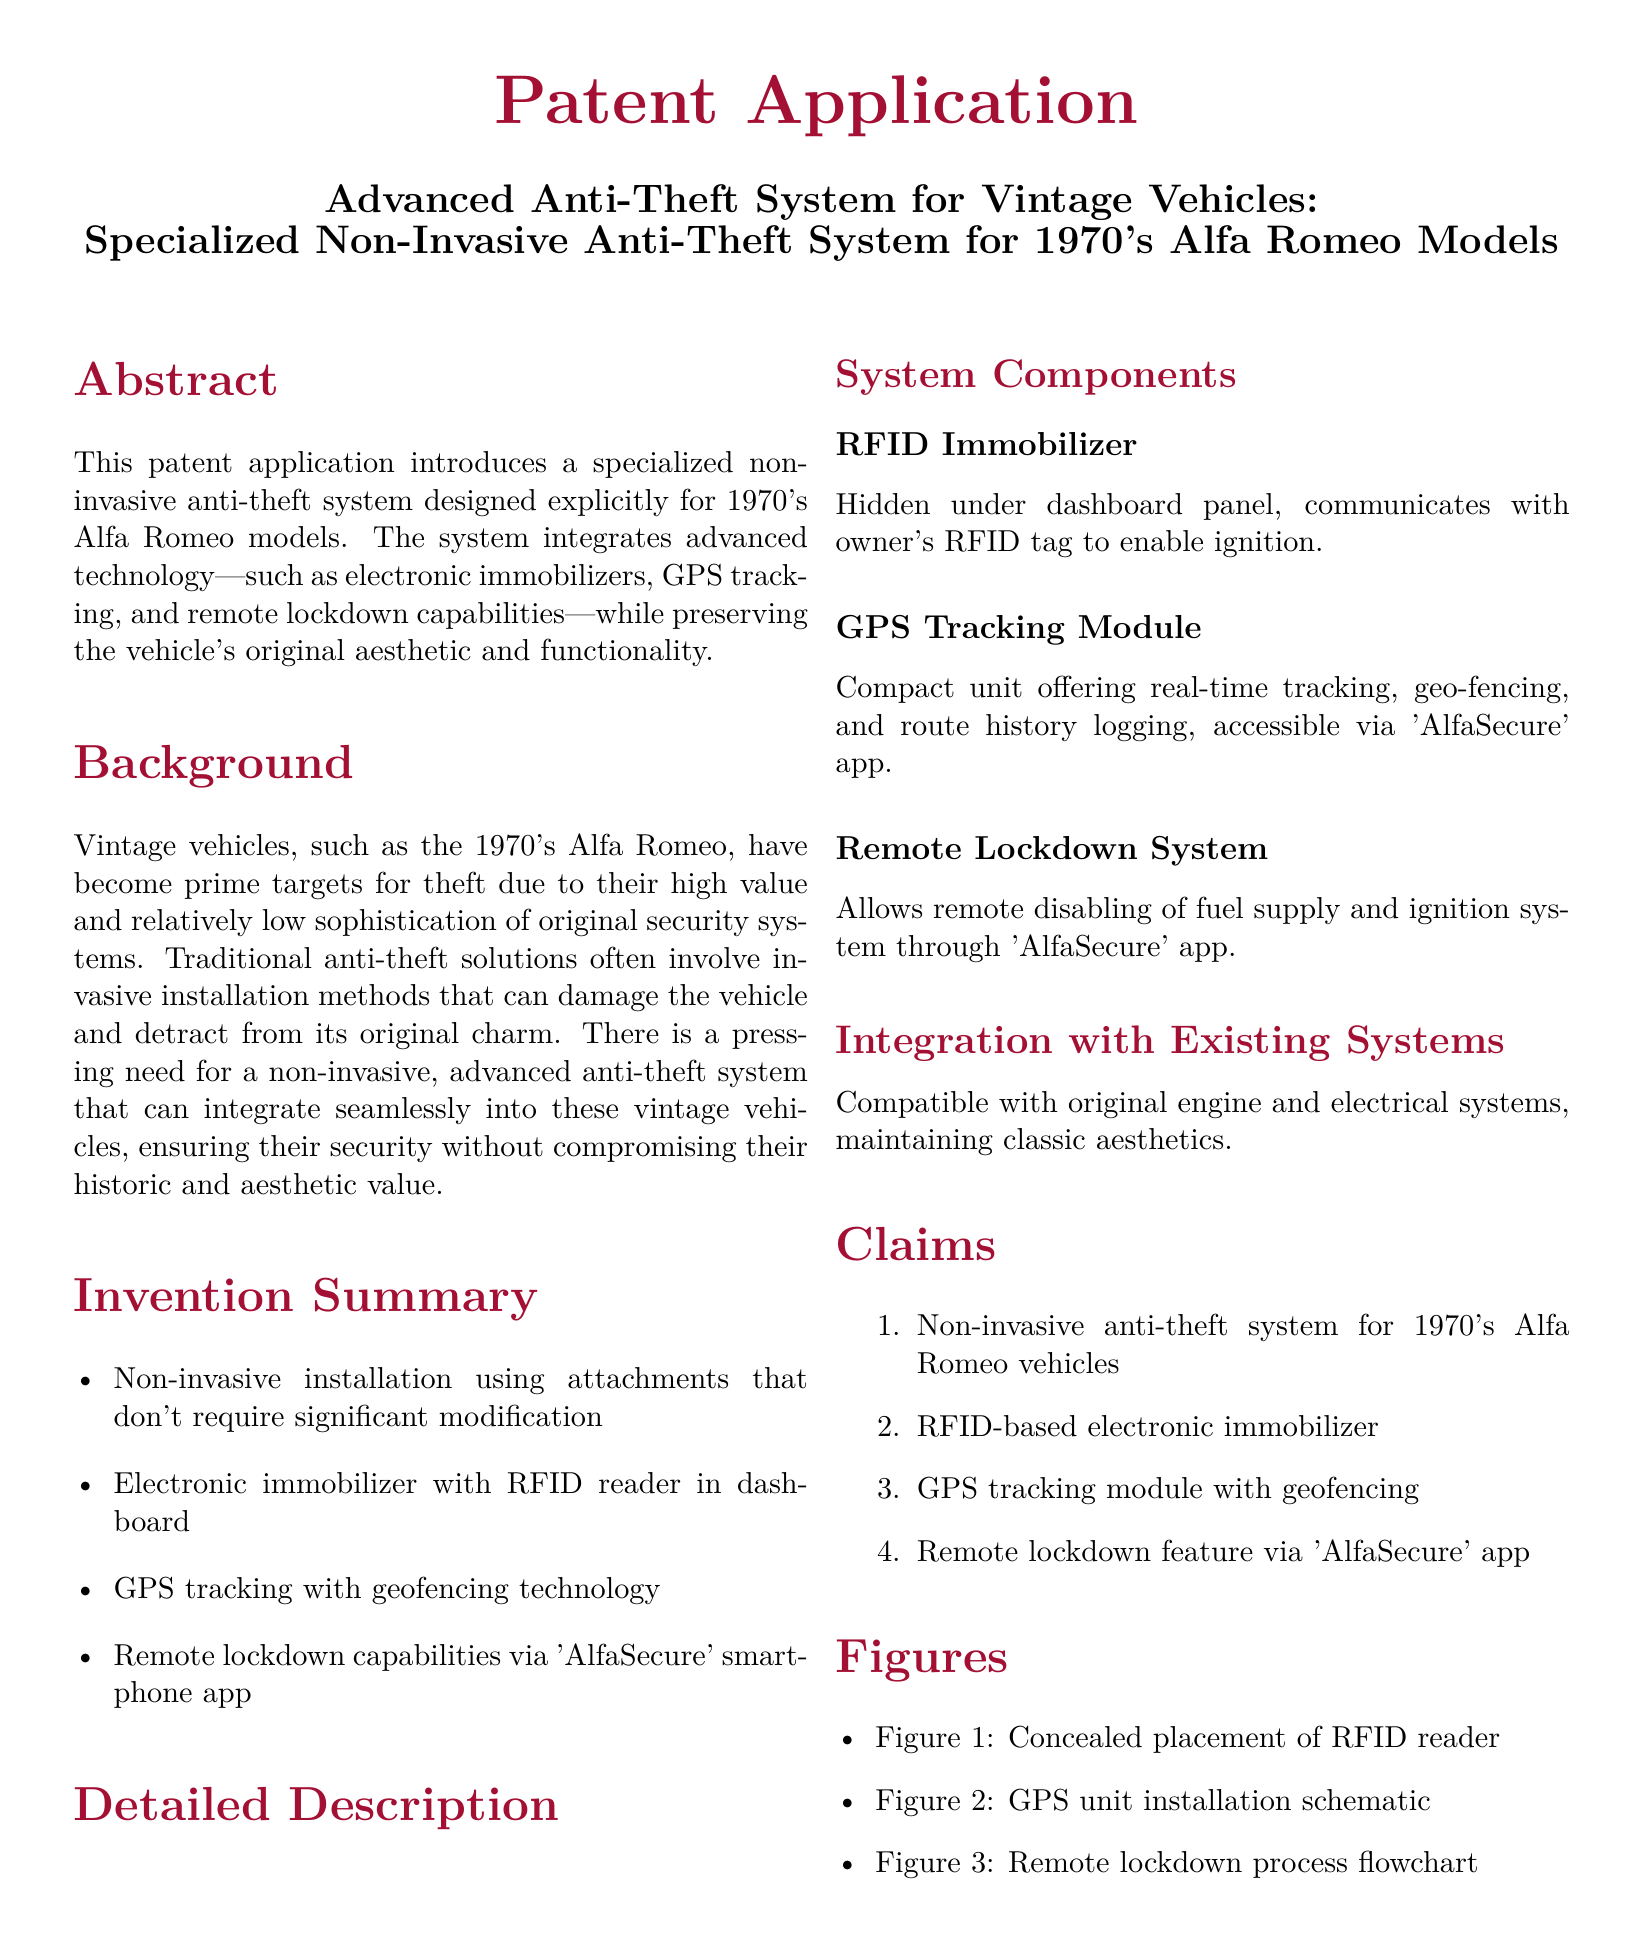What is the title of the patent application? The title of the patent application is located at the top of the document.
Answer: Advanced Anti-Theft System for Vintage Vehicles: Specialized Non-Invasive Anti-Theft System for 1970's Alfa Romeo Models What year models does the anti-theft system target? The document specifies the targeted vehicle models in the invention summary section.
Answer: 1970's What technology is used for the electronic immobilizer? The document mentions the technology used for the immobilizer in the detailed description section.
Answer: RFID What is the name of the smartphone app associated with the system? The app's name is clearly mentioned in the invention summary and detailed description sections.
Answer: AlfaSecure What are the three main components of the system? The document lists the main components in the invention summary section.
Answer: RFID Immobilizer, GPS Tracking Module, Remote Lockdown System How does the remote lockdown system function? The function of the remote lockdown system is explained in the detailed description section.
Answer: Remote disabling of fuel supply and ignition system What installation approach does the invention use? The installation approach is stated in the invention summary section.
Answer: Non-invasive installation What figure illustrates the placement of the RFID reader? The document includes a reference to figures in the figures section.
Answer: Figure 1 How many claims are made in the patent application? The number of claims is listed in the claims section.
Answer: Four 